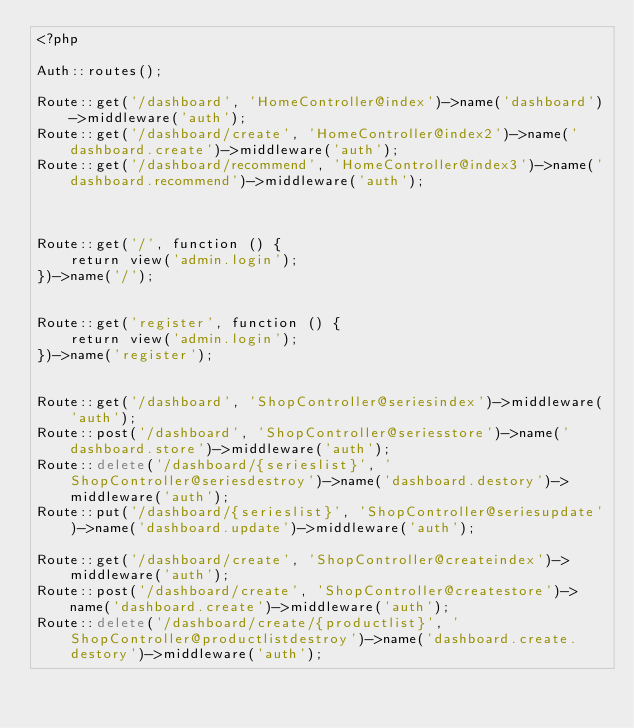<code> <loc_0><loc_0><loc_500><loc_500><_PHP_><?php

Auth::routes();

Route::get('/dashboard', 'HomeController@index')->name('dashboard')->middleware('auth');
Route::get('/dashboard/create', 'HomeController@index2')->name('dashboard.create')->middleware('auth');
Route::get('/dashboard/recommend', 'HomeController@index3')->name('dashboard.recommend')->middleware('auth');



Route::get('/', function () {
    return view('admin.login');
})->name('/');


Route::get('register', function () {
    return view('admin.login');
})->name('register');


Route::get('/dashboard', 'ShopController@seriesindex')->middleware('auth');
Route::post('/dashboard', 'ShopController@seriesstore')->name('dashboard.store')->middleware('auth');
Route::delete('/dashboard/{serieslist}', 'ShopController@seriesdestroy')->name('dashboard.destory')->middleware('auth');
Route::put('/dashboard/{serieslist}', 'ShopController@seriesupdate')->name('dashboard.update')->middleware('auth');

Route::get('/dashboard/create', 'ShopController@createindex')->middleware('auth');
Route::post('/dashboard/create', 'ShopController@createstore')->name('dashboard.create')->middleware('auth');
Route::delete('/dashboard/create/{productlist}', 'ShopController@productlistdestroy')->name('dashboard.create.destory')->middleware('auth');</code> 